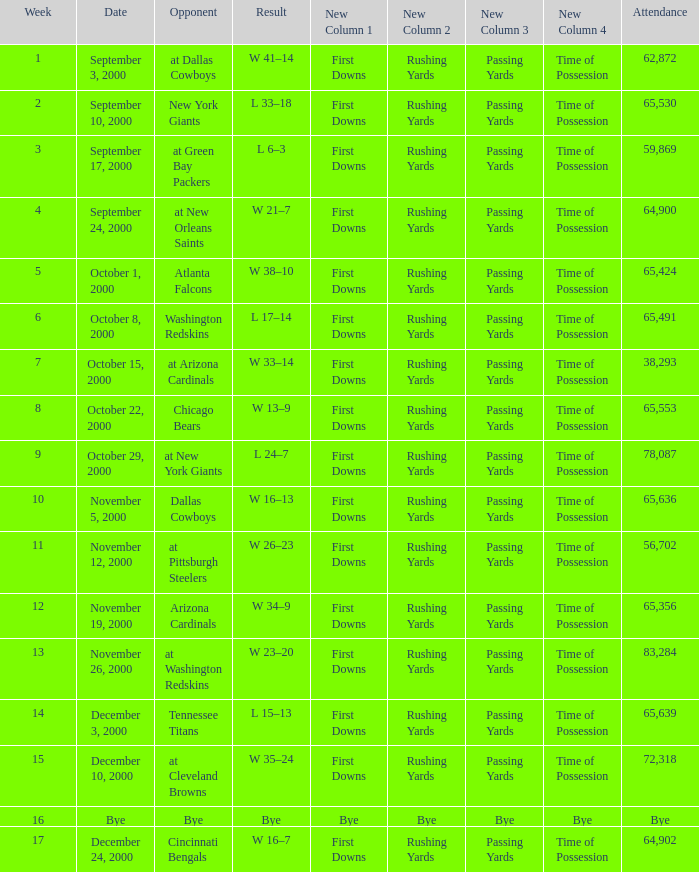What was the attendance when the Cincinnati Bengals were the opponents? 64902.0. Parse the table in full. {'header': ['Week', 'Date', 'Opponent', 'Result', 'New Column 1', 'New Column 2', 'New Column 3', 'New Column 4', 'Attendance'], 'rows': [['1', 'September 3, 2000', 'at Dallas Cowboys', 'W 41–14', 'First Downs', 'Rushing Yards', 'Passing Yards', 'Time of Possession', '62,872'], ['2', 'September 10, 2000', 'New York Giants', 'L 33–18', 'First Downs', 'Rushing Yards', 'Passing Yards', 'Time of Possession', '65,530'], ['3', 'September 17, 2000', 'at Green Bay Packers', 'L 6–3', 'First Downs', 'Rushing Yards', 'Passing Yards', 'Time of Possession', '59,869'], ['4', 'September 24, 2000', 'at New Orleans Saints', 'W 21–7', 'First Downs', 'Rushing Yards', 'Passing Yards', 'Time of Possession', '64,900'], ['5', 'October 1, 2000', 'Atlanta Falcons', 'W 38–10', 'First Downs', 'Rushing Yards', 'Passing Yards', 'Time of Possession', '65,424'], ['6', 'October 8, 2000', 'Washington Redskins', 'L 17–14', 'First Downs', 'Rushing Yards', 'Passing Yards', 'Time of Possession', '65,491'], ['7', 'October 15, 2000', 'at Arizona Cardinals', 'W 33–14', 'First Downs', 'Rushing Yards', 'Passing Yards', 'Time of Possession', '38,293'], ['8', 'October 22, 2000', 'Chicago Bears', 'W 13–9', 'First Downs', 'Rushing Yards', 'Passing Yards', 'Time of Possession', '65,553'], ['9', 'October 29, 2000', 'at New York Giants', 'L 24–7', 'First Downs', 'Rushing Yards', 'Passing Yards', 'Time of Possession', '78,087'], ['10', 'November 5, 2000', 'Dallas Cowboys', 'W 16–13', 'First Downs', 'Rushing Yards', 'Passing Yards', 'Time of Possession', '65,636'], ['11', 'November 12, 2000', 'at Pittsburgh Steelers', 'W 26–23', 'First Downs', 'Rushing Yards', 'Passing Yards', 'Time of Possession', '56,702'], ['12', 'November 19, 2000', 'Arizona Cardinals', 'W 34–9', 'First Downs', 'Rushing Yards', 'Passing Yards', 'Time of Possession', '65,356'], ['13', 'November 26, 2000', 'at Washington Redskins', 'W 23–20', 'First Downs', 'Rushing Yards', 'Passing Yards', 'Time of Possession', '83,284'], ['14', 'December 3, 2000', 'Tennessee Titans', 'L 15–13', 'First Downs', 'Rushing Yards', 'Passing Yards', 'Time of Possession', '65,639'], ['15', 'December 10, 2000', 'at Cleveland Browns', 'W 35–24', 'First Downs', 'Rushing Yards', 'Passing Yards', 'Time of Possession', '72,318'], ['16', 'Bye', 'Bye', 'Bye', 'Bye', 'Bye', 'Bye', 'Bye', 'Bye'], ['17', 'December 24, 2000', 'Cincinnati Bengals', 'W 16–7', 'First Downs', 'Rushing Yards', 'Passing Yards', 'Time of Possession', '64,902']]} 